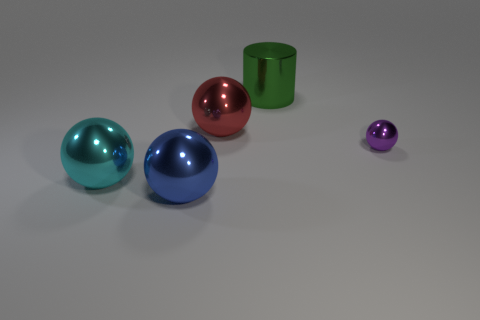What color is the shiny thing behind the large metallic sphere behind the tiny ball?
Your answer should be compact. Green. Is there a green matte cube of the same size as the blue metal object?
Offer a terse response. No. There is a large thing right of the large ball behind the sphere that is right of the green metallic thing; what is it made of?
Your response must be concise. Metal. There is a thing that is right of the metallic cylinder; how many purple shiny spheres are to the right of it?
Give a very brief answer. 0. Does the thing left of the blue metallic sphere have the same size as the green object?
Provide a succinct answer. Yes. What number of big cyan objects have the same shape as the purple metallic object?
Ensure brevity in your answer.  1. What is the shape of the big blue shiny object?
Your answer should be compact. Sphere. Is the number of big red things in front of the large metal cylinder the same as the number of large gray rubber cylinders?
Provide a succinct answer. No. Is the number of objects behind the cyan metallic object less than the number of big cyan metal balls?
Your answer should be compact. No. What number of rubber things are large things or big blocks?
Ensure brevity in your answer.  0. 